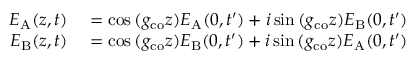Convert formula to latex. <formula><loc_0><loc_0><loc_500><loc_500>\begin{array} { r l } { E _ { A } ( z , t ) } & = \cos { ( g _ { c o } z ) } E _ { A } ( 0 , t ^ { \prime } ) + i \sin { ( g _ { c o } z ) } E _ { B } ( 0 , t ^ { \prime } ) } \\ { E _ { B } ( z , t ) } & = \cos { ( g _ { c o } z ) } E _ { B } ( 0 , t ^ { \prime } ) + i \sin { ( g _ { c o } z ) } E _ { A } ( 0 , t ^ { \prime } ) } \end{array}</formula> 